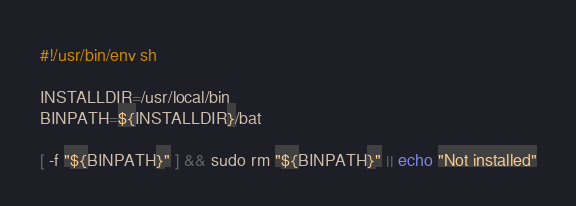<code> <loc_0><loc_0><loc_500><loc_500><_Bash_>#!/usr/bin/env sh

INSTALLDIR=/usr/local/bin
BINPATH=${INSTALLDIR}/bat

[ -f "${BINPATH}" ] && sudo rm "${BINPATH}" || echo "Not installed"
</code> 